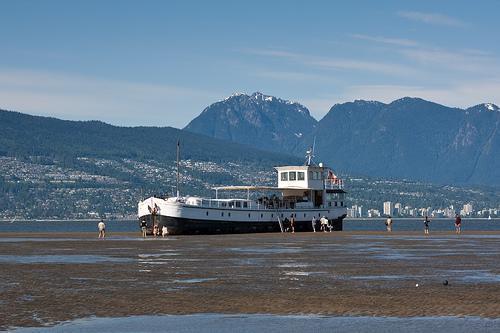How many oranges with barcode stickers?
Give a very brief answer. 0. 